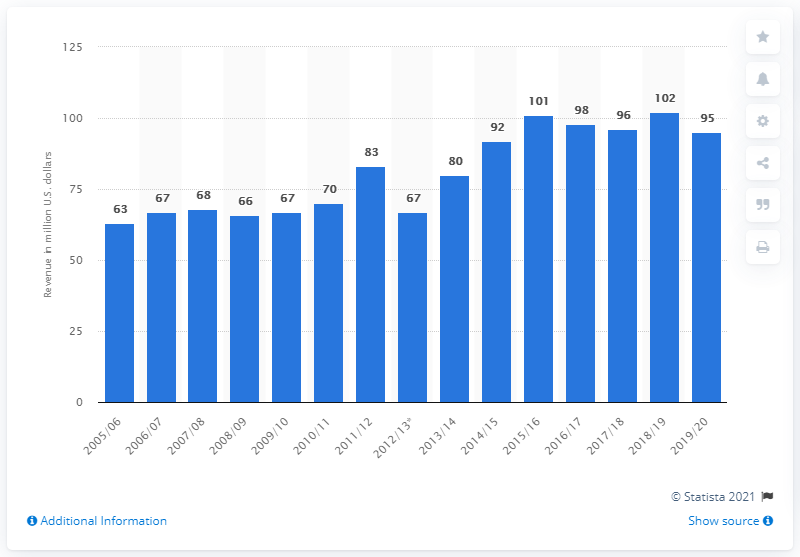Specify some key components in this picture. The Arizona Coyotes earned approximately $95 million in the 2019/2020 season. 